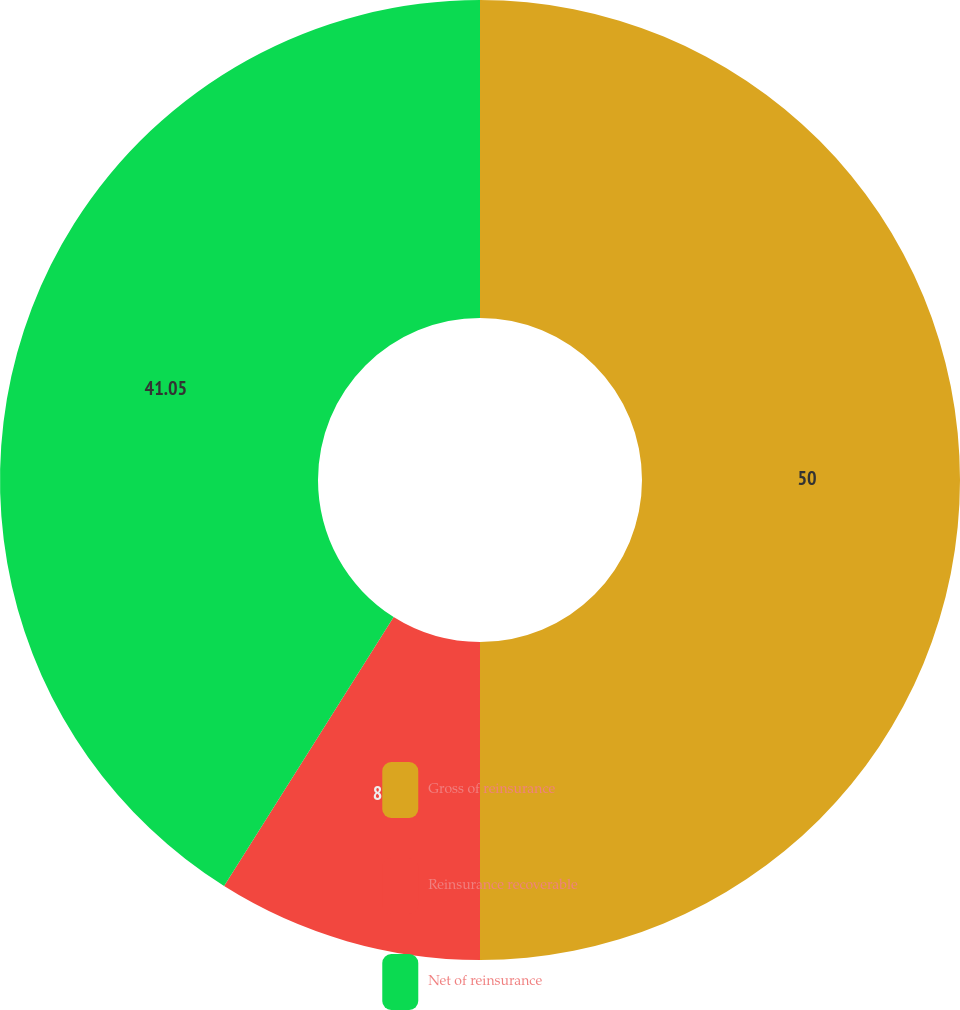<chart> <loc_0><loc_0><loc_500><loc_500><pie_chart><fcel>Gross of reinsurance<fcel>Reinsurance recoverable<fcel>Net of reinsurance<nl><fcel>50.0%<fcel>8.95%<fcel>41.05%<nl></chart> 